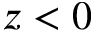<formula> <loc_0><loc_0><loc_500><loc_500>z < 0</formula> 